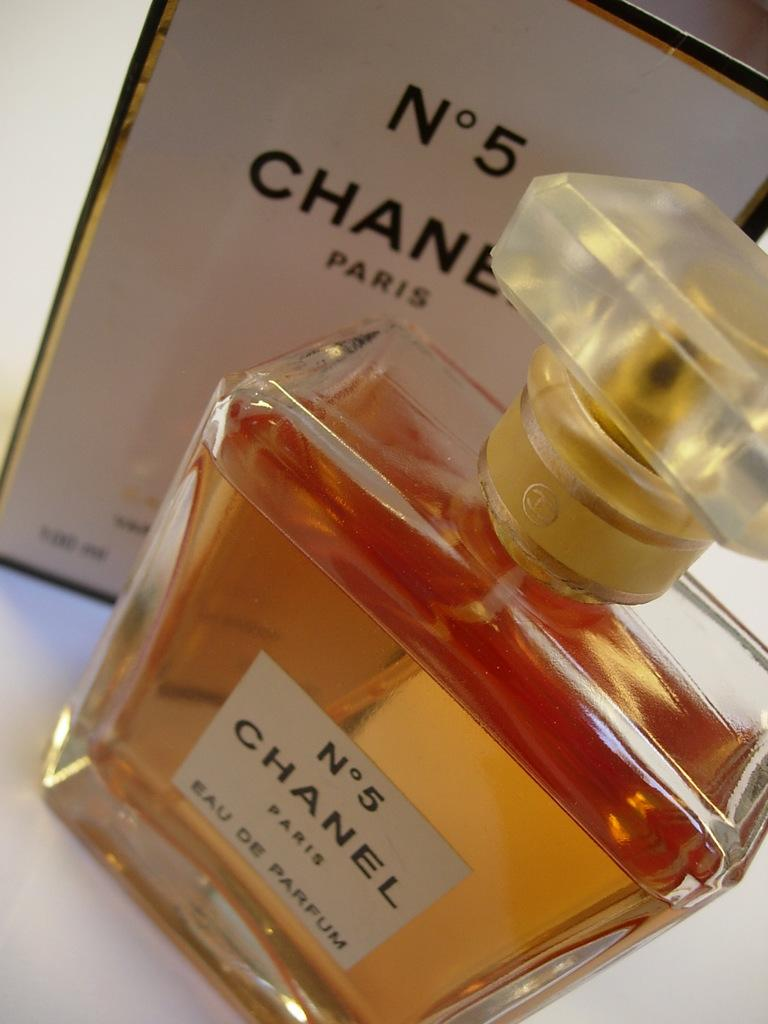Provide a one-sentence caption for the provided image. A bottle of Chanel No. 5 sits in front of its box. 